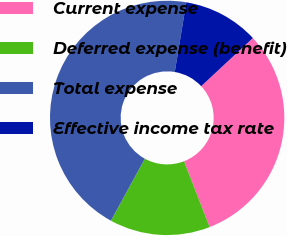<chart> <loc_0><loc_0><loc_500><loc_500><pie_chart><fcel>Current expense<fcel>Deferred expense (benefit)<fcel>Total expense<fcel>Effective income tax rate<nl><fcel>31.03%<fcel>13.87%<fcel>44.65%<fcel>10.45%<nl></chart> 